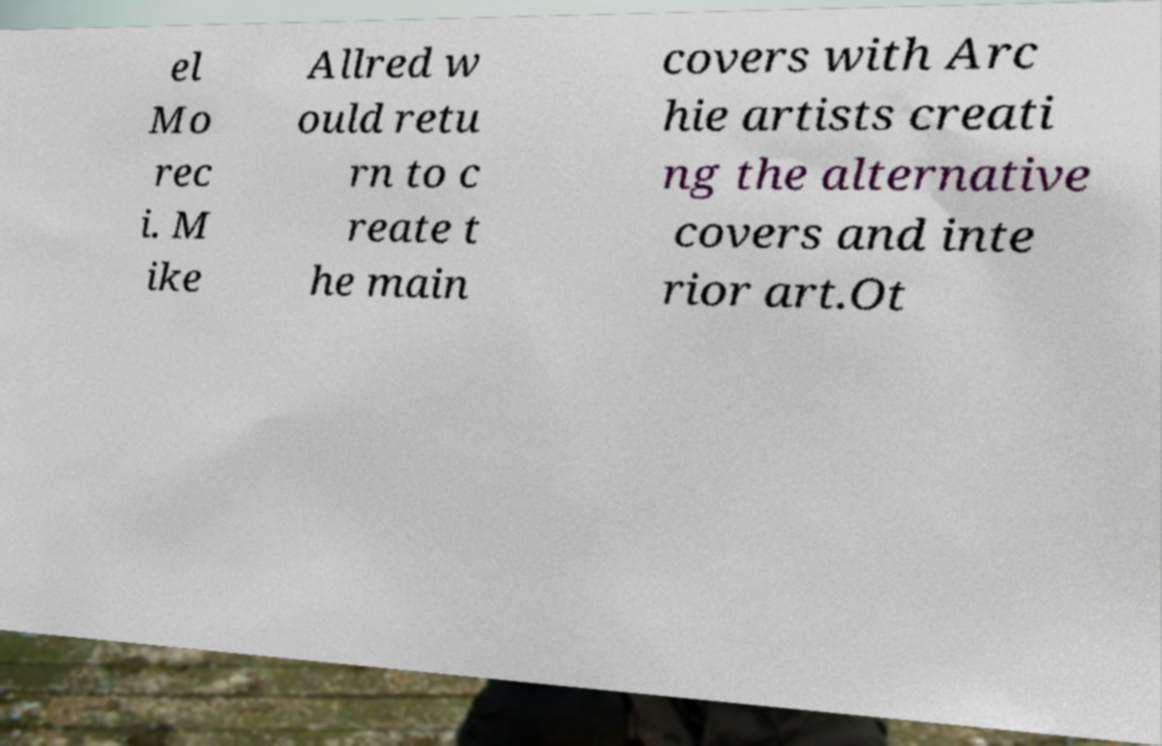Could you assist in decoding the text presented in this image and type it out clearly? el Mo rec i. M ike Allred w ould retu rn to c reate t he main covers with Arc hie artists creati ng the alternative covers and inte rior art.Ot 